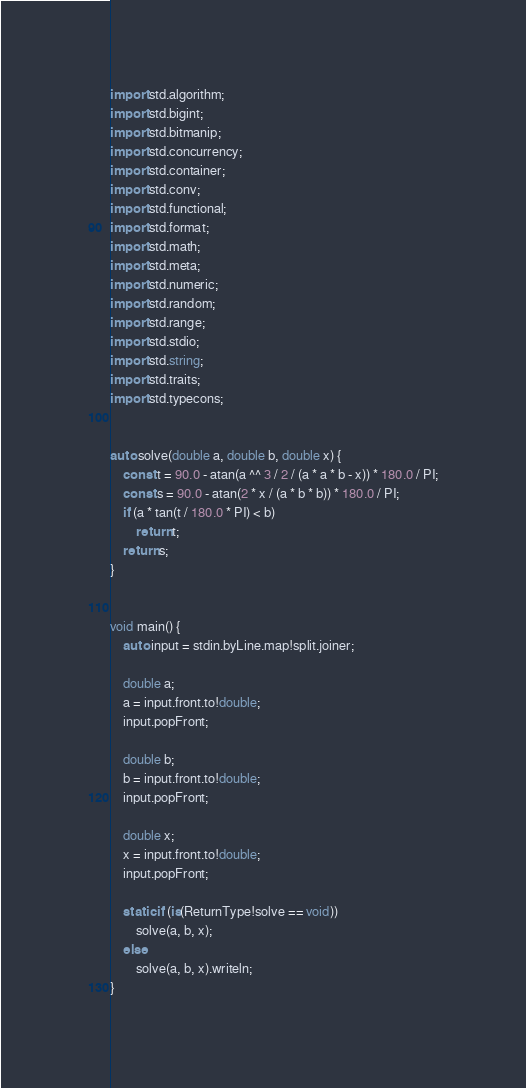Convert code to text. <code><loc_0><loc_0><loc_500><loc_500><_D_>import std.algorithm;
import std.bigint;
import std.bitmanip;
import std.concurrency;
import std.container;
import std.conv;
import std.functional;
import std.format;
import std.math;
import std.meta;
import std.numeric;
import std.random;
import std.range;
import std.stdio;
import std.string;
import std.traits;
import std.typecons;


auto solve(double a, double b, double x) {
    const t = 90.0 - atan(a ^^ 3 / 2 / (a * a * b - x)) * 180.0 / PI;
    const s = 90.0 - atan(2 * x / (a * b * b)) * 180.0 / PI;
    if (a * tan(t / 180.0 * PI) < b)
        return t;
    return s;
}


void main() {
    auto input = stdin.byLine.map!split.joiner;

    double a;
    a = input.front.to!double;
    input.popFront;

    double b;
    b = input.front.to!double;
    input.popFront;

    double x;
    x = input.front.to!double;
    input.popFront;

    static if (is(ReturnType!solve == void))
        solve(a, b, x);
    else
        solve(a, b, x).writeln;
}
</code> 